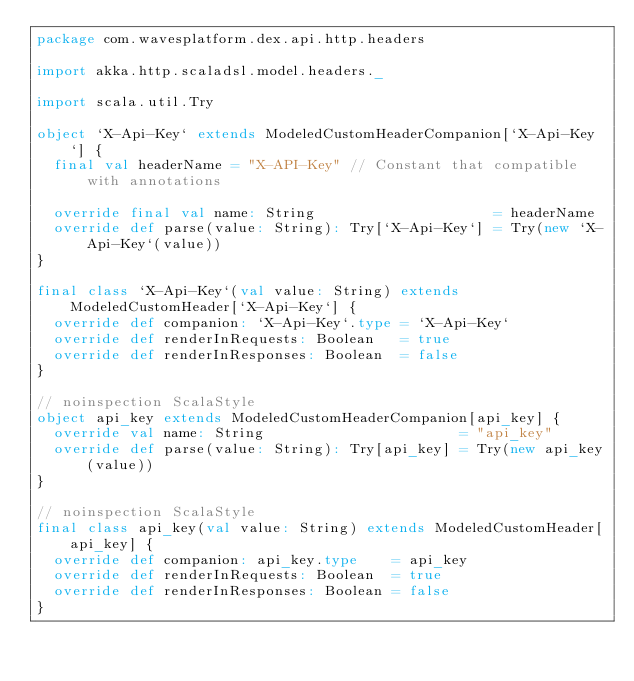<code> <loc_0><loc_0><loc_500><loc_500><_Scala_>package com.wavesplatform.dex.api.http.headers

import akka.http.scaladsl.model.headers._

import scala.util.Try

object `X-Api-Key` extends ModeledCustomHeaderCompanion[`X-Api-Key`] {
  final val headerName = "X-API-Key" // Constant that compatible with annotations

  override final val name: String                     = headerName
  override def parse(value: String): Try[`X-Api-Key`] = Try(new `X-Api-Key`(value))
}

final class `X-Api-Key`(val value: String) extends ModeledCustomHeader[`X-Api-Key`] {
  override def companion: `X-Api-Key`.type = `X-Api-Key`
  override def renderInRequests: Boolean   = true
  override def renderInResponses: Boolean  = false
}

// noinspection ScalaStyle
object api_key extends ModeledCustomHeaderCompanion[api_key] {
  override val name: String                       = "api_key"
  override def parse(value: String): Try[api_key] = Try(new api_key(value))
}

// noinspection ScalaStyle
final class api_key(val value: String) extends ModeledCustomHeader[api_key] {
  override def companion: api_key.type    = api_key
  override def renderInRequests: Boolean  = true
  override def renderInResponses: Boolean = false
}
</code> 